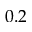<formula> <loc_0><loc_0><loc_500><loc_500>0 . 2</formula> 